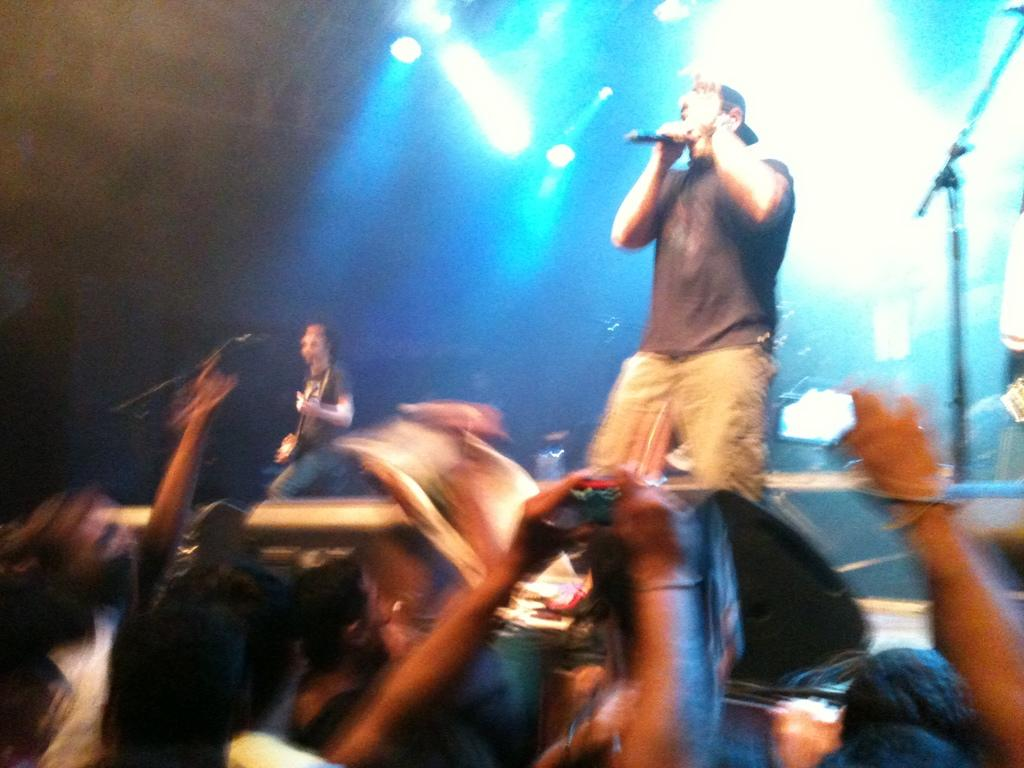What type of event is taking place in the image? It is a music concert. Who is the main performer on stage? A man is standing on the stage. What is the man doing on stage? The man is singing a song. How is the audience reacting to the performance? There is a crowd present at the concert, and they are enjoying the music. What can be seen in the background of the image? There are different lights in the background. How many cents are visible on the stage during the performance? There are no cents visible on the stage during the performance. What year is the concert taking place in the image? The provided facts do not mention the year, so it cannot be determined from the image. 